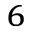<formula> <loc_0><loc_0><loc_500><loc_500>^ { 6 }</formula> 